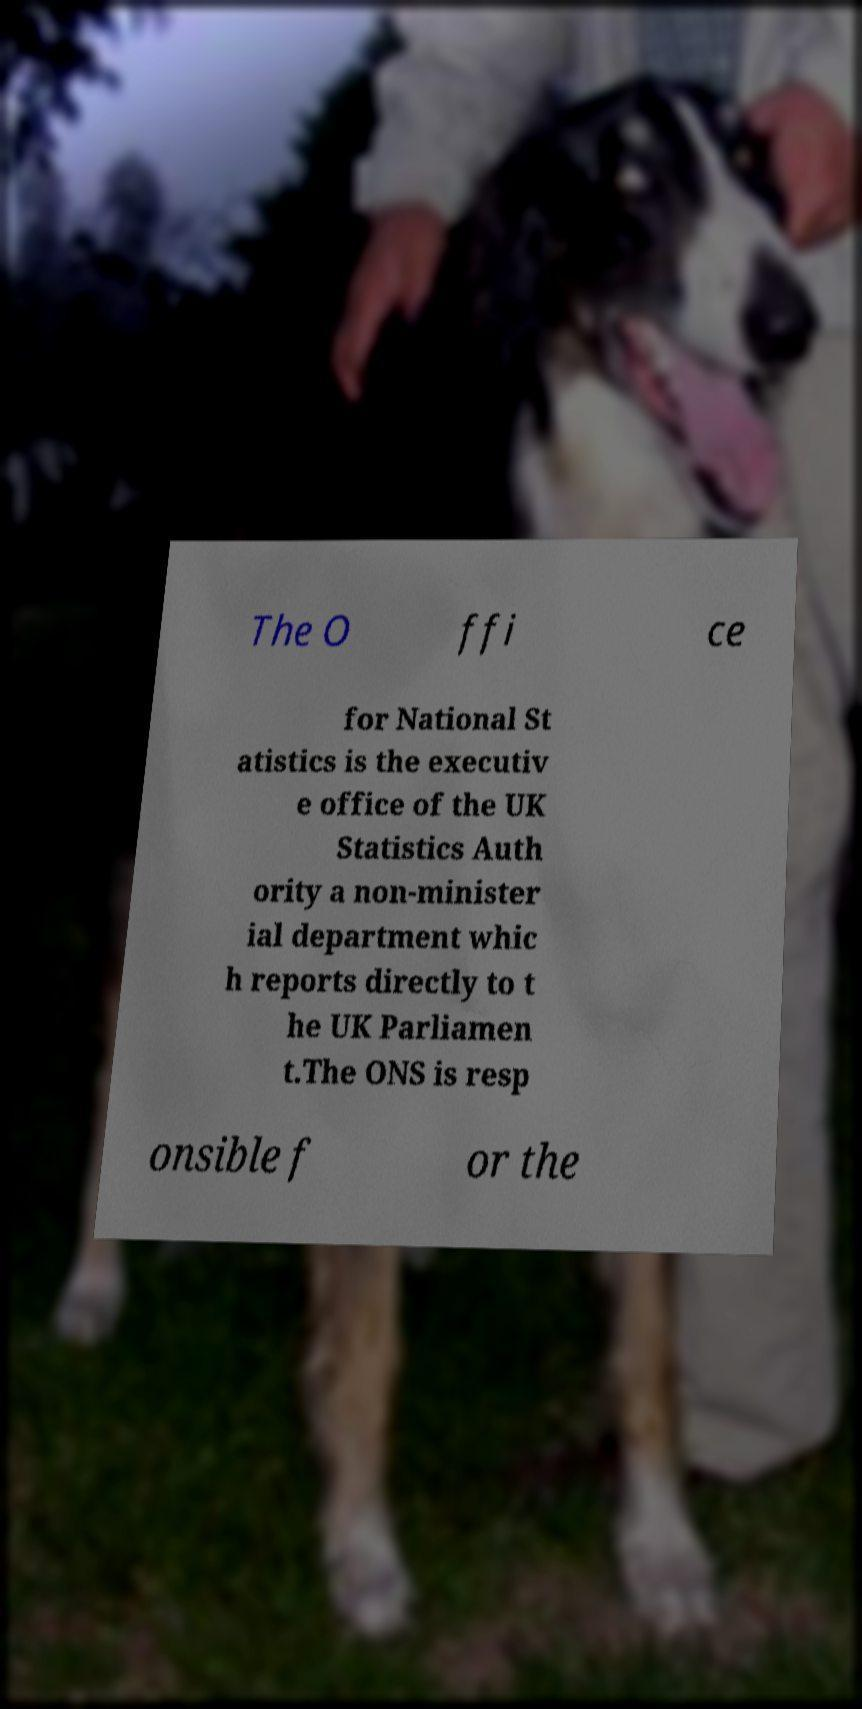Can you accurately transcribe the text from the provided image for me? The O ffi ce for National St atistics is the executiv e office of the UK Statistics Auth ority a non-minister ial department whic h reports directly to t he UK Parliamen t.The ONS is resp onsible f or the 